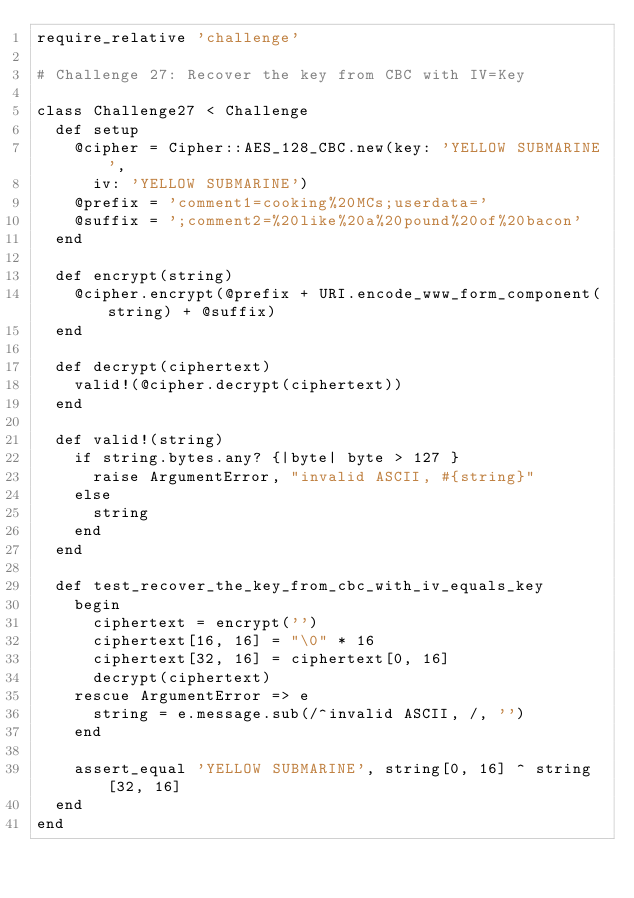<code> <loc_0><loc_0><loc_500><loc_500><_Ruby_>require_relative 'challenge'

# Challenge 27: Recover the key from CBC with IV=Key

class Challenge27 < Challenge
  def setup
    @cipher = Cipher::AES_128_CBC.new(key: 'YELLOW SUBMARINE',
      iv: 'YELLOW SUBMARINE')
    @prefix = 'comment1=cooking%20MCs;userdata='
    @suffix = ';comment2=%20like%20a%20pound%20of%20bacon'
  end

  def encrypt(string)
    @cipher.encrypt(@prefix + URI.encode_www_form_component(string) + @suffix)
  end

  def decrypt(ciphertext)
    valid!(@cipher.decrypt(ciphertext))
  end

  def valid!(string)
    if string.bytes.any? {|byte| byte > 127 }
      raise ArgumentError, "invalid ASCII, #{string}"
    else
      string
    end
  end

  def test_recover_the_key_from_cbc_with_iv_equals_key
    begin
      ciphertext = encrypt('')
      ciphertext[16, 16] = "\0" * 16
      ciphertext[32, 16] = ciphertext[0, 16]
      decrypt(ciphertext)
    rescue ArgumentError => e
      string = e.message.sub(/^invalid ASCII, /, '')
    end

    assert_equal 'YELLOW SUBMARINE', string[0, 16] ^ string[32, 16]
  end
end
</code> 